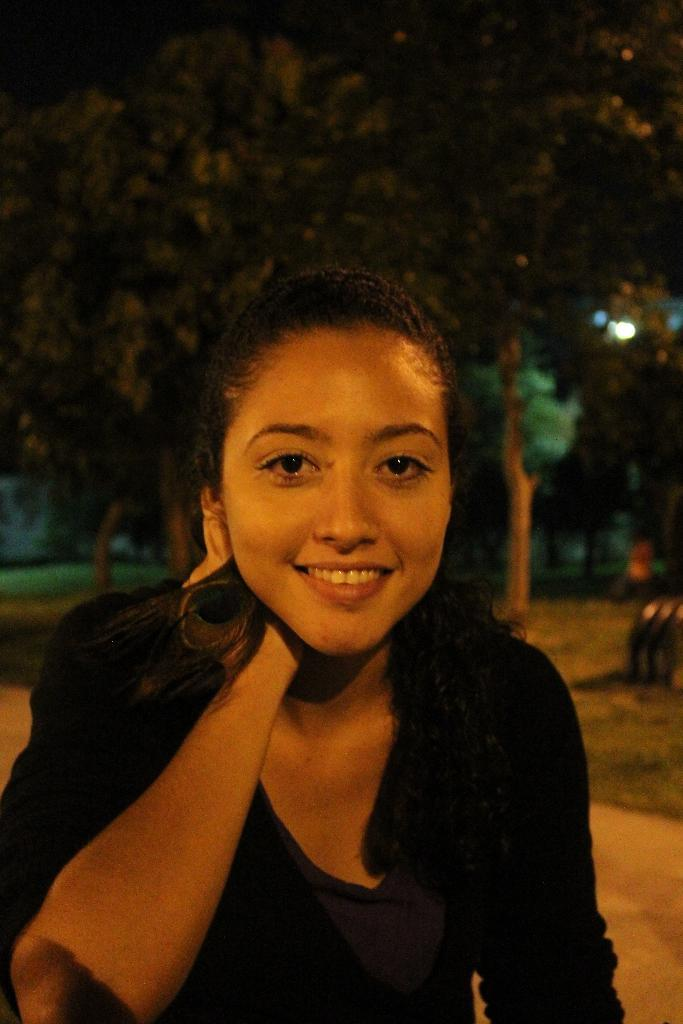Who is the main subject in the image? There is a woman in the image. What can be seen in the background of the image? There are trees and lights in the background of the image. What type of bomb can be seen in the image? There is no bomb present in the image. 